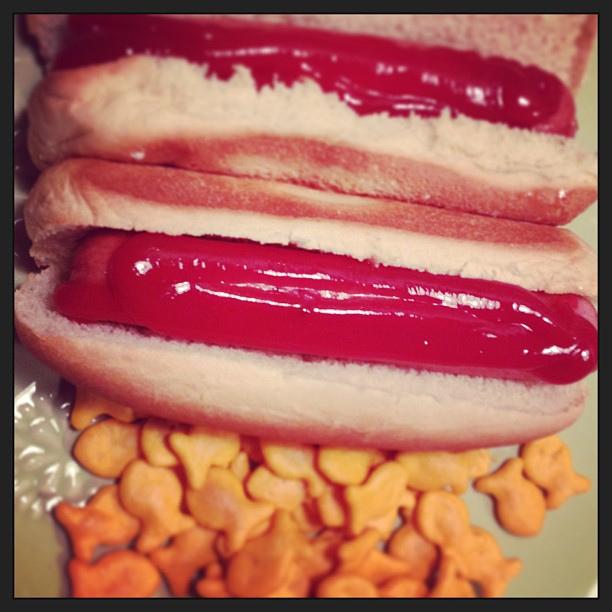Do the hotdogs have condiments on them?
Be succinct. Yes. What type of snack is sitting next to the hot dogs?
Quick response, please. Goldfish. How many hot dogs are there?
Concise answer only. 2. Is there mustard on these hot dogs?
Write a very short answer. No. What is the name of the company that makes these hot dogs?
Short answer required. Oscar mayer. 